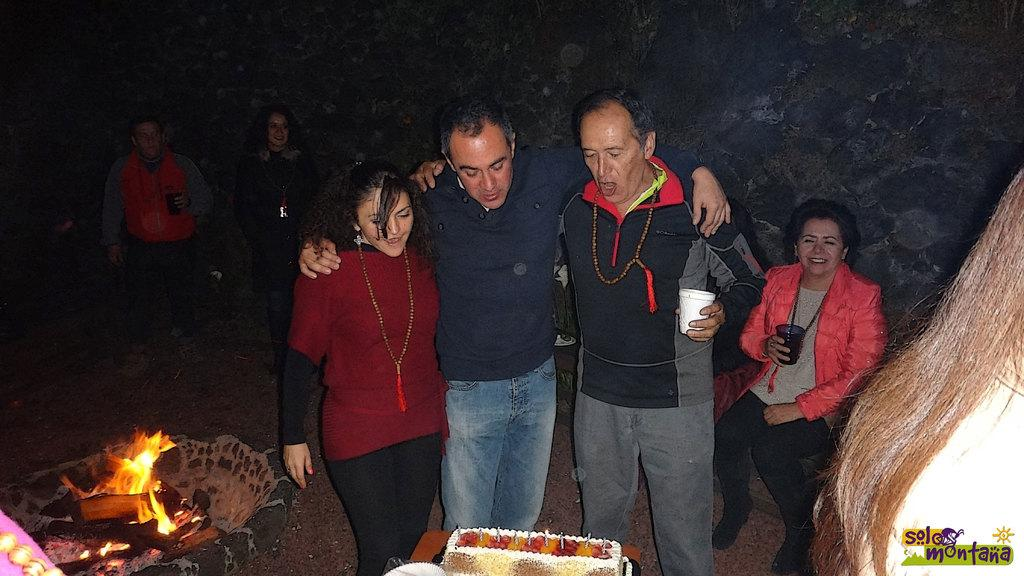Who or what is present in the image? There are people in the image. What objects can be seen in the image? There are glasses in the image. What is the source of light in the image? There is fire in the image, which could be the source of light. What type of natural environment is visible in the image? There are trees in the image, indicating a natural environment. Where is the mine located in the image? There is no mine present in the image. What type of glove is being used by the people in the image? There is no glove visible in the image. 